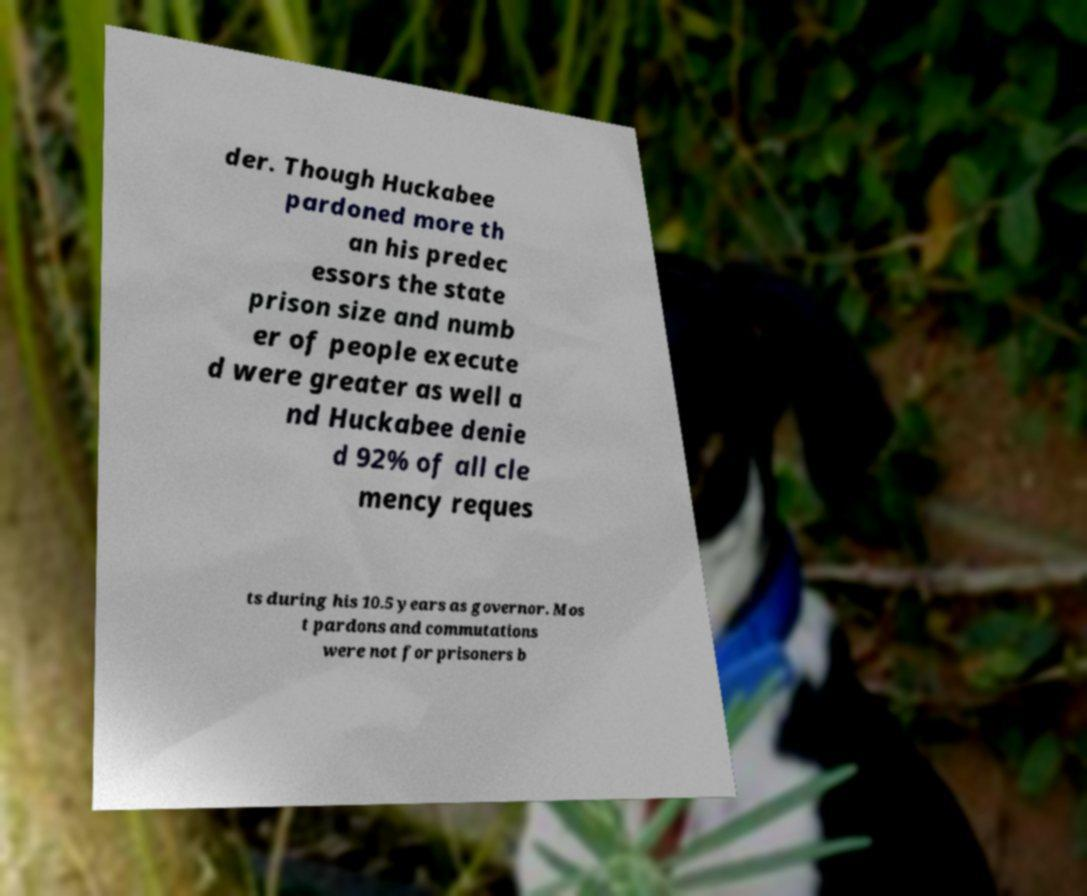Could you assist in decoding the text presented in this image and type it out clearly? der. Though Huckabee pardoned more th an his predec essors the state prison size and numb er of people execute d were greater as well a nd Huckabee denie d 92% of all cle mency reques ts during his 10.5 years as governor. Mos t pardons and commutations were not for prisoners b 